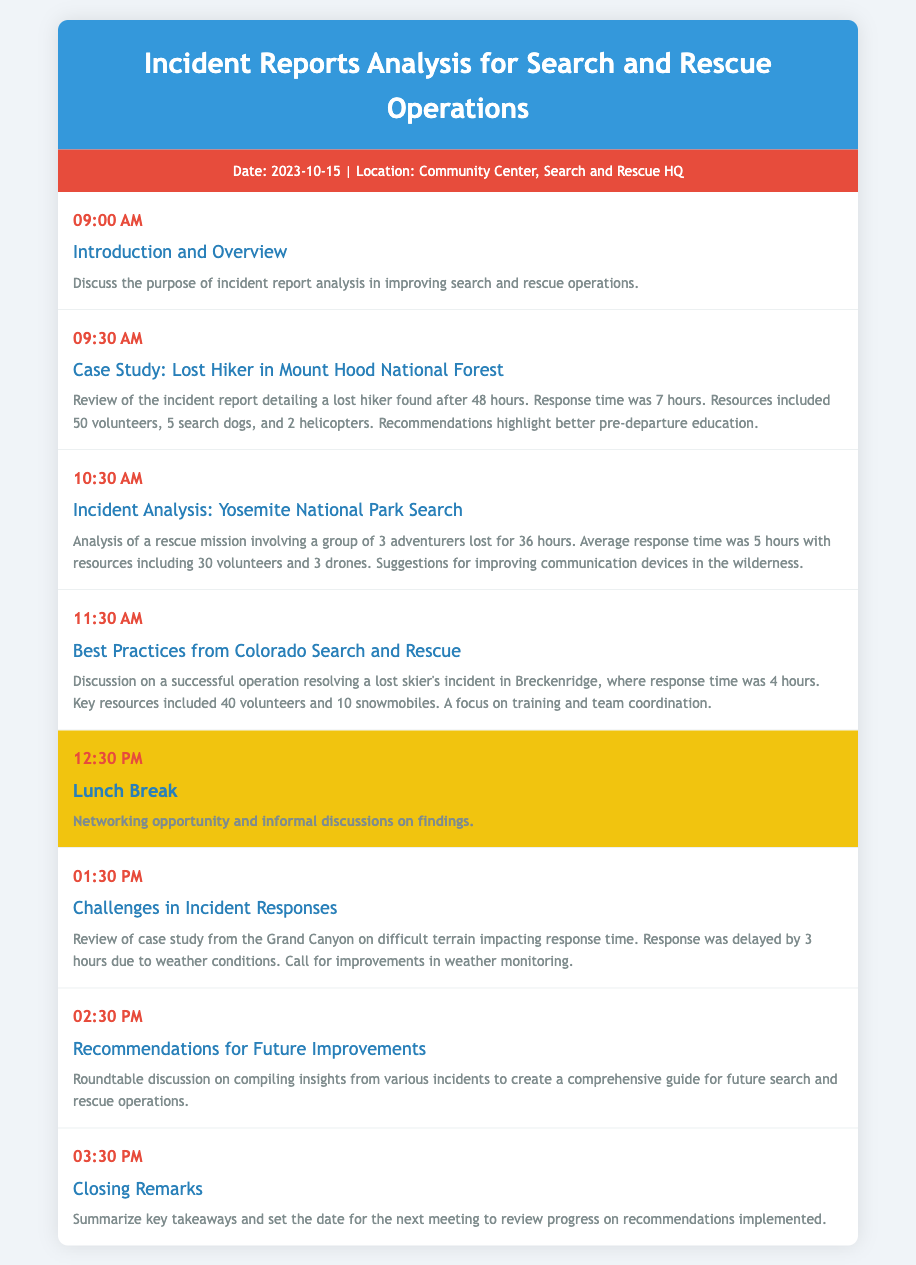What is the date of the meeting? The date of the meeting is mentioned in the meta info section of the document.
Answer: 2023-10-15 What is the first agenda item? The first agenda item is listed at 09:00 AM in the agenda section of the document.
Answer: Introduction and Overview How long was the lost hiker missing in Mount Hood National Forest? The duration the lost hiker was missing is specified in the case study detail.
Answer: 48 hours How many volunteers were involved in the Yosemite National Park search? The number of volunteers used in the Yosemite search mission is noted in the incident analysis.
Answer: 30 volunteers What was the response time for the lost skier in Breckenridge? The response time for the skier incident is recorded in the best practices discussion.
Answer: 4 hours What time is the lunch break scheduled? The time for the lunch break is clearly stated in the agenda.
Answer: 12:30 PM What is discussed in the Challenges in Incident Responses section? The challenges related to incident responses are elaborated in the corresponding agenda item.
Answer: Weather conditions What is the primary focus of the Recommendations for Future Improvements? The main focus of this agenda item is described in the discussion overview.
Answer: Comprehensive guide How many search dogs were used in the Mount Hood incident? The specific number of search dogs is provided in the case study detail for that incident.
Answer: 5 search dogs 